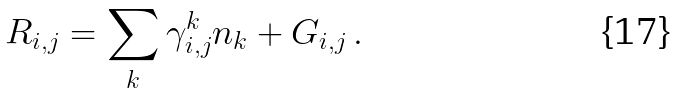Convert formula to latex. <formula><loc_0><loc_0><loc_500><loc_500>R _ { i , j } = \sum _ { k } \gamma ^ { k } _ { i , j } n _ { k } + G _ { i , j } \, .</formula> 